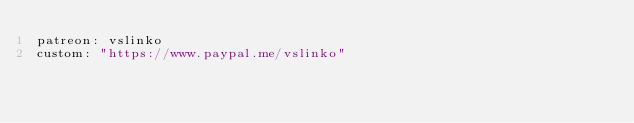<code> <loc_0><loc_0><loc_500><loc_500><_YAML_>patreon: vslinko
custom: "https://www.paypal.me/vslinko"
</code> 